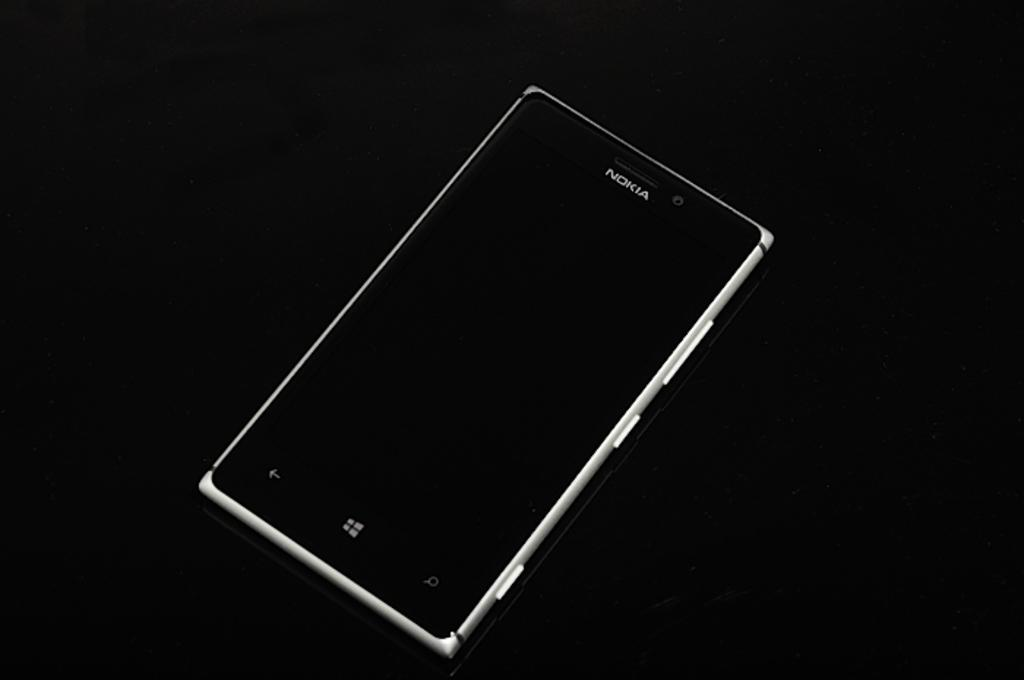<image>
Render a clear and concise summary of the photo. A Nokia device sits un-powered on a black surface. 